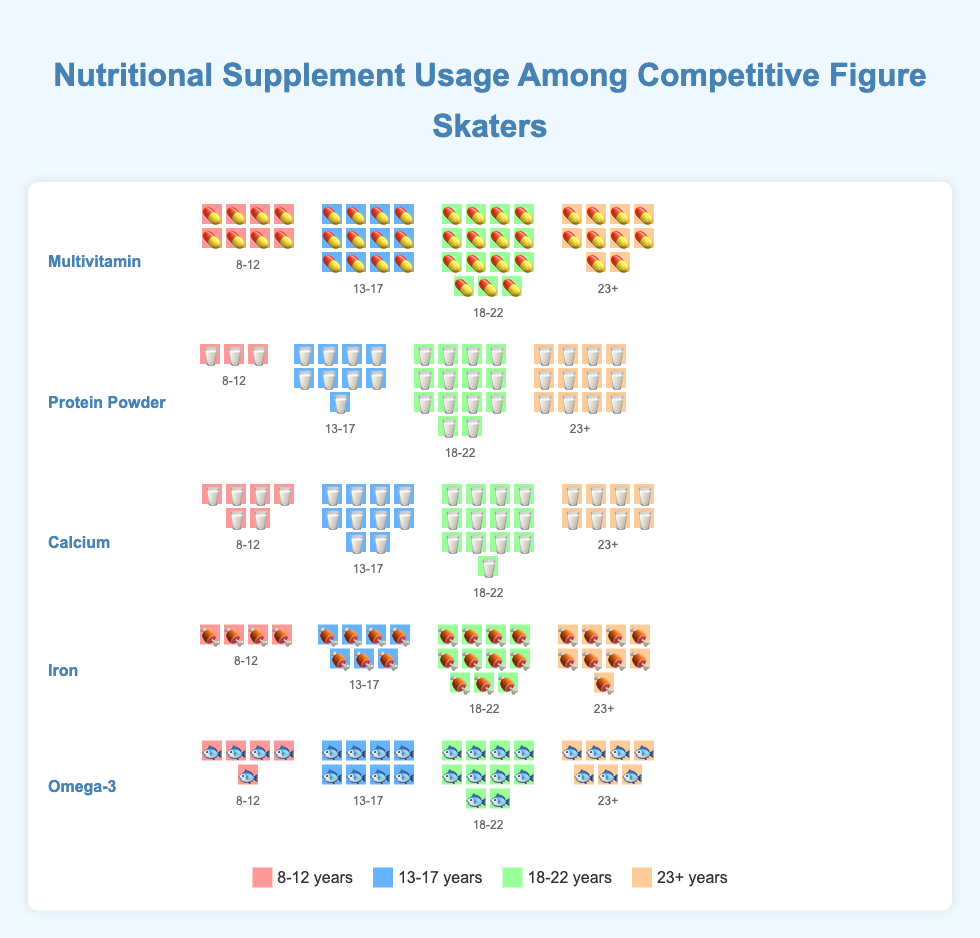Which supplement is used the most by the 13-17 age group? This question requires identifying the usage count for each supplement within the 13-17 age group and finding the highest value. Multivitamin is used by 12 skaters, Protein Powder by 9, Calcium by 10, Iron by 7, and Omega-3 by 8 in this age group. The highest value is 12 for Multivitamin.
Answer: Multivitamin Which age group uses Protein Powder the most? This question requires identifying the highest usage of Protein Powder across all age groups. The usage value of Protein Powder is 3 for 8-12, 9 for 13-17, 14 for 18-22, and 12 for 23+. The highest value is 14 for the 18-22 age group.
Answer: 18-22 What is the total usage of Calcium across all age groups? This question involves summing the usage values for Calcium: 6 (8-12) + 10 (13-17) + 13 (18-22) + 8 (23+). The calculation: 6 + 10 + 13 + 8 = 37.
Answer: 37 Which supplement is least used by the 23+ age group? This question requires identifying the smallest usage number for each supplement within the 23+ age group. The usage values are Multivitamin 10, Protein Powder 12, Calcium 8, Iron 9, and Omega-3 7. The smallest value is 7 for Omega-3.
Answer: Omega-3 How does the usage of Iron in the 13-17 age group compare to the 18-22 age group? This question requires comparing the usage numbers for Iron between two age groups. The usage is 7 for 13-17 and 11 for 18-22. Therefore, Iron usage in 18-22 is higher than in 13-17 by 4 units.
Answer: Higher by 4 units On average, how many skaters use Protein Powder in each age group? This question requires calculating the mean usage of Protein Powder across all age groups. The usage is 3 (8-12), 9 (13-17), 14 (18-22), and 12 (23+). The sum is 3 + 9 + 14 + 12 = 38. The average is 38/4 = 9.5.
Answer: 9.5 Which age group has the highest total supplement usage? This question involves summing the usage values for all supplements within each age group and comparing them. The totals are:
8-12: 8+3+6+4+5=26,
13-17: 12+9+10+7+8=46,
18-22: 15+14+13+11+10=63,
23+: 10+12+8+9+7=46.
The highest total is 63 for the 18-22 age group.
Answer: 18-22 Which supplement shows the least variability in usage across age groups? This question involves comparing the range of usage values of each supplement across age groups. Multivitamin ranges from 8 to 15 (range of 7), Protein Powder from 3 to 14 (range of 11), Calcium from 6 to 13 (range of 7), Iron from 4 to 11 (range of 7), and Omega-3 from 5 to 10 (range of 5). Omega-3 has the smallest range of 5.
Answer: Omega-3 What is the difference in usage of Multivitamins between the 8-12 and 18-22 age groups? This question requires comparing the Multivitamin usage between two age groups. The usage is 8 for 8-12 and 15 for 18-22. The difference is 15 - 8 = 7.
Answer: 7 